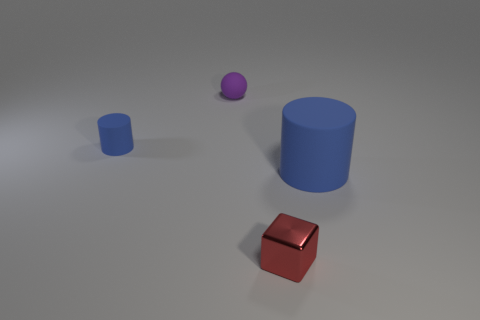What time of day does the lighting in the image suggest? The image itself does not provide direct clues about the time of day, as the lighting appears neutral and artificial, resembling studio lighting. This type of illumination is consistent with an indoor setting where time of day is not indicated by the light source. 